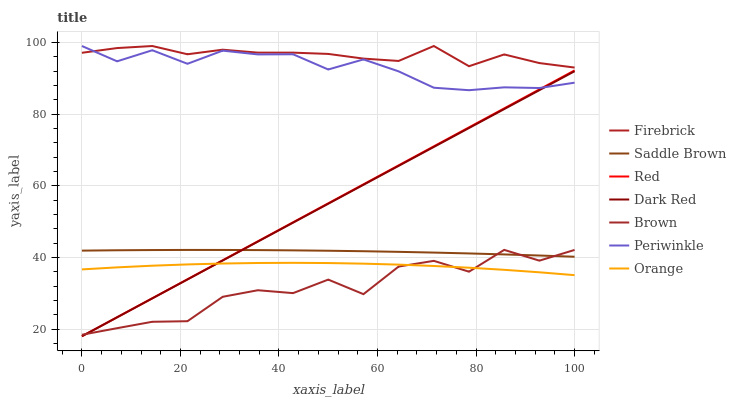Does Brown have the minimum area under the curve?
Answer yes or no. Yes. Does Firebrick have the maximum area under the curve?
Answer yes or no. Yes. Does Dark Red have the minimum area under the curve?
Answer yes or no. No. Does Dark Red have the maximum area under the curve?
Answer yes or no. No. Is Red the smoothest?
Answer yes or no. Yes. Is Brown the roughest?
Answer yes or no. Yes. Is Dark Red the smoothest?
Answer yes or no. No. Is Dark Red the roughest?
Answer yes or no. No. Does Dark Red have the lowest value?
Answer yes or no. Yes. Does Firebrick have the lowest value?
Answer yes or no. No. Does Periwinkle have the highest value?
Answer yes or no. Yes. Does Dark Red have the highest value?
Answer yes or no. No. Is Brown less than Periwinkle?
Answer yes or no. Yes. Is Firebrick greater than Dark Red?
Answer yes or no. Yes. Does Brown intersect Red?
Answer yes or no. Yes. Is Brown less than Red?
Answer yes or no. No. Is Brown greater than Red?
Answer yes or no. No. Does Brown intersect Periwinkle?
Answer yes or no. No. 